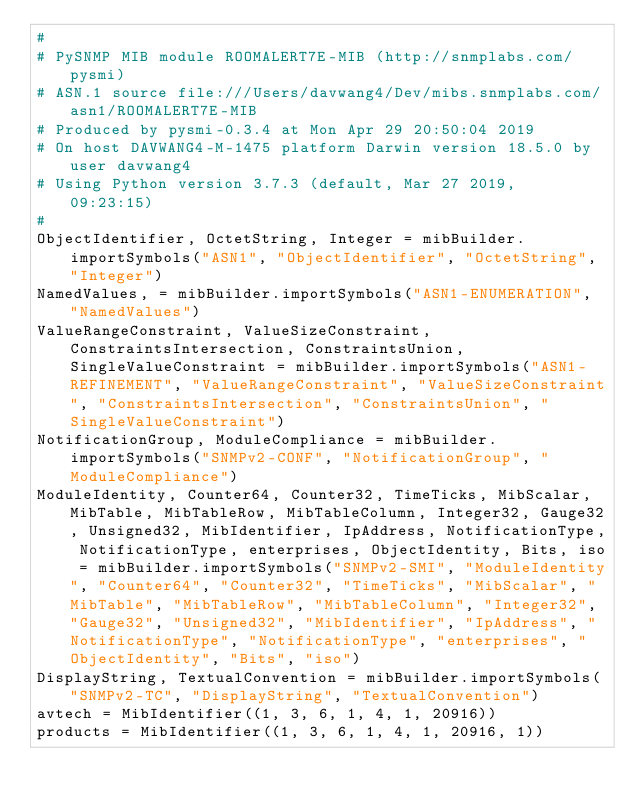<code> <loc_0><loc_0><loc_500><loc_500><_Python_>#
# PySNMP MIB module ROOMALERT7E-MIB (http://snmplabs.com/pysmi)
# ASN.1 source file:///Users/davwang4/Dev/mibs.snmplabs.com/asn1/ROOMALERT7E-MIB
# Produced by pysmi-0.3.4 at Mon Apr 29 20:50:04 2019
# On host DAVWANG4-M-1475 platform Darwin version 18.5.0 by user davwang4
# Using Python version 3.7.3 (default, Mar 27 2019, 09:23:15) 
#
ObjectIdentifier, OctetString, Integer = mibBuilder.importSymbols("ASN1", "ObjectIdentifier", "OctetString", "Integer")
NamedValues, = mibBuilder.importSymbols("ASN1-ENUMERATION", "NamedValues")
ValueRangeConstraint, ValueSizeConstraint, ConstraintsIntersection, ConstraintsUnion, SingleValueConstraint = mibBuilder.importSymbols("ASN1-REFINEMENT", "ValueRangeConstraint", "ValueSizeConstraint", "ConstraintsIntersection", "ConstraintsUnion", "SingleValueConstraint")
NotificationGroup, ModuleCompliance = mibBuilder.importSymbols("SNMPv2-CONF", "NotificationGroup", "ModuleCompliance")
ModuleIdentity, Counter64, Counter32, TimeTicks, MibScalar, MibTable, MibTableRow, MibTableColumn, Integer32, Gauge32, Unsigned32, MibIdentifier, IpAddress, NotificationType, NotificationType, enterprises, ObjectIdentity, Bits, iso = mibBuilder.importSymbols("SNMPv2-SMI", "ModuleIdentity", "Counter64", "Counter32", "TimeTicks", "MibScalar", "MibTable", "MibTableRow", "MibTableColumn", "Integer32", "Gauge32", "Unsigned32", "MibIdentifier", "IpAddress", "NotificationType", "NotificationType", "enterprises", "ObjectIdentity", "Bits", "iso")
DisplayString, TextualConvention = mibBuilder.importSymbols("SNMPv2-TC", "DisplayString", "TextualConvention")
avtech = MibIdentifier((1, 3, 6, 1, 4, 1, 20916))
products = MibIdentifier((1, 3, 6, 1, 4, 1, 20916, 1))</code> 